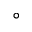<formula> <loc_0><loc_0><loc_500><loc_500>^ { \circ }</formula> 